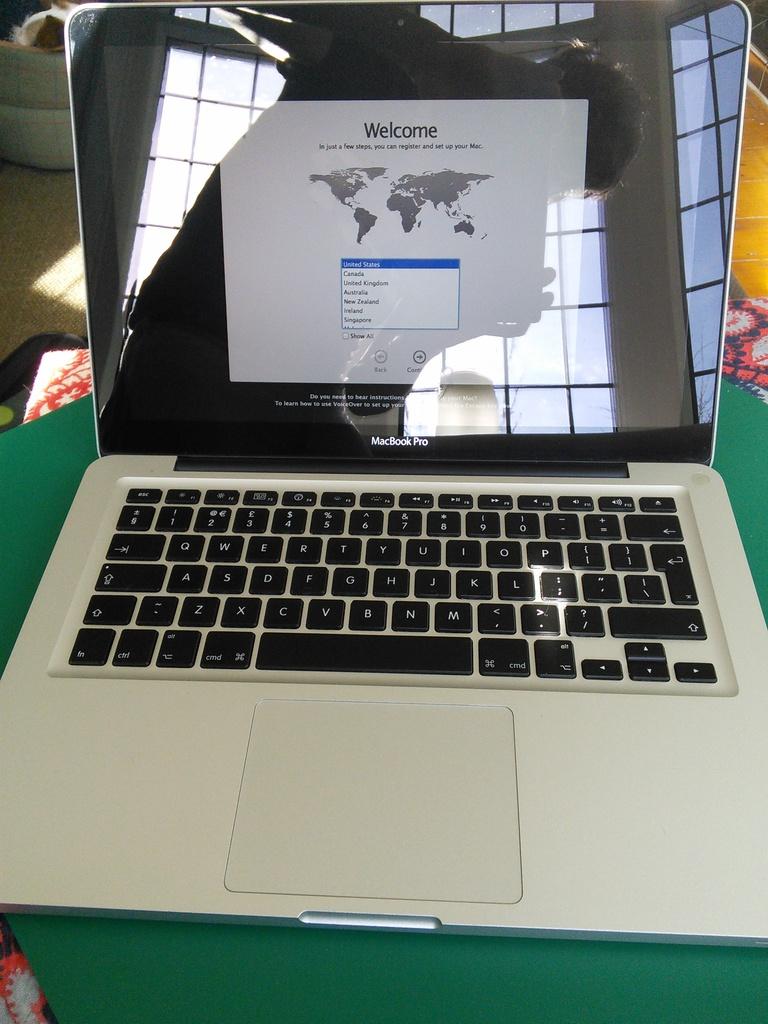What is the first word on this webpage?
Give a very brief answer. Welcome. What is the greeting on the screen?
Provide a succinct answer. Welcome. 